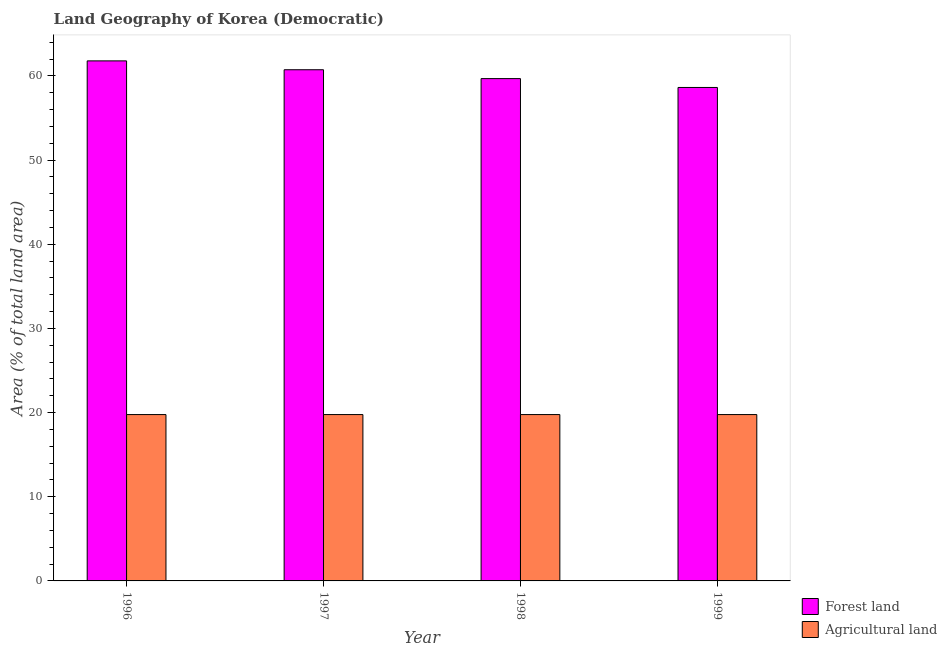How many different coloured bars are there?
Provide a succinct answer. 2. What is the label of the 1st group of bars from the left?
Your answer should be very brief. 1996. In how many cases, is the number of bars for a given year not equal to the number of legend labels?
Provide a succinct answer. 0. What is the percentage of land area under forests in 1999?
Your response must be concise. 58.63. Across all years, what is the maximum percentage of land area under forests?
Keep it short and to the point. 61.79. Across all years, what is the minimum percentage of land area under forests?
Offer a terse response. 58.63. In which year was the percentage of land area under agriculture maximum?
Ensure brevity in your answer.  1996. In which year was the percentage of land area under agriculture minimum?
Your answer should be compact. 1996. What is the total percentage of land area under forests in the graph?
Provide a succinct answer. 240.84. What is the difference between the percentage of land area under forests in 1996 and that in 1998?
Keep it short and to the point. 2.11. What is the difference between the percentage of land area under forests in 1998 and the percentage of land area under agriculture in 1999?
Ensure brevity in your answer.  1.05. What is the average percentage of land area under agriculture per year?
Give a very brief answer. 19.77. In the year 1999, what is the difference between the percentage of land area under agriculture and percentage of land area under forests?
Your response must be concise. 0. In how many years, is the percentage of land area under agriculture greater than 30 %?
Make the answer very short. 0. What is the ratio of the percentage of land area under forests in 1997 to that in 1999?
Provide a succinct answer. 1.04. Is the percentage of land area under forests in 1997 less than that in 1998?
Your answer should be compact. No. Is the difference between the percentage of land area under agriculture in 1996 and 1999 greater than the difference between the percentage of land area under forests in 1996 and 1999?
Your answer should be compact. No. What is the difference between the highest and the lowest percentage of land area under forests?
Ensure brevity in your answer.  3.16. In how many years, is the percentage of land area under agriculture greater than the average percentage of land area under agriculture taken over all years?
Your answer should be very brief. 0. Is the sum of the percentage of land area under agriculture in 1996 and 1999 greater than the maximum percentage of land area under forests across all years?
Ensure brevity in your answer.  Yes. What does the 1st bar from the left in 1996 represents?
Your answer should be compact. Forest land. What does the 1st bar from the right in 1996 represents?
Offer a very short reply. Agricultural land. How many bars are there?
Your answer should be compact. 8. Are all the bars in the graph horizontal?
Give a very brief answer. No. How many years are there in the graph?
Provide a short and direct response. 4. What is the difference between two consecutive major ticks on the Y-axis?
Offer a terse response. 10. Are the values on the major ticks of Y-axis written in scientific E-notation?
Your answer should be very brief. No. Does the graph contain any zero values?
Your answer should be very brief. No. How many legend labels are there?
Your answer should be very brief. 2. How are the legend labels stacked?
Keep it short and to the point. Vertical. What is the title of the graph?
Offer a terse response. Land Geography of Korea (Democratic). Does "Grants" appear as one of the legend labels in the graph?
Your response must be concise. No. What is the label or title of the Y-axis?
Offer a very short reply. Area (% of total land area). What is the Area (% of total land area) in Forest land in 1996?
Provide a succinct answer. 61.79. What is the Area (% of total land area) in Agricultural land in 1996?
Ensure brevity in your answer.  19.77. What is the Area (% of total land area) in Forest land in 1997?
Ensure brevity in your answer.  60.74. What is the Area (% of total land area) in Agricultural land in 1997?
Your response must be concise. 19.77. What is the Area (% of total land area) of Forest land in 1998?
Provide a succinct answer. 59.68. What is the Area (% of total land area) in Agricultural land in 1998?
Offer a terse response. 19.77. What is the Area (% of total land area) in Forest land in 1999?
Give a very brief answer. 58.63. What is the Area (% of total land area) of Agricultural land in 1999?
Your answer should be very brief. 19.77. Across all years, what is the maximum Area (% of total land area) of Forest land?
Offer a terse response. 61.79. Across all years, what is the maximum Area (% of total land area) of Agricultural land?
Offer a terse response. 19.77. Across all years, what is the minimum Area (% of total land area) in Forest land?
Your answer should be compact. 58.63. Across all years, what is the minimum Area (% of total land area) in Agricultural land?
Your answer should be compact. 19.77. What is the total Area (% of total land area) of Forest land in the graph?
Your answer should be very brief. 240.84. What is the total Area (% of total land area) in Agricultural land in the graph?
Offer a terse response. 79.06. What is the difference between the Area (% of total land area) of Forest land in 1996 and that in 1997?
Provide a short and direct response. 1.05. What is the difference between the Area (% of total land area) in Forest land in 1996 and that in 1998?
Provide a short and direct response. 2.11. What is the difference between the Area (% of total land area) in Forest land in 1996 and that in 1999?
Give a very brief answer. 3.16. What is the difference between the Area (% of total land area) in Forest land in 1997 and that in 1998?
Provide a succinct answer. 1.05. What is the difference between the Area (% of total land area) of Forest land in 1997 and that in 1999?
Provide a succinct answer. 2.11. What is the difference between the Area (% of total land area) in Forest land in 1998 and that in 1999?
Make the answer very short. 1.05. What is the difference between the Area (% of total land area) of Agricultural land in 1998 and that in 1999?
Provide a short and direct response. 0. What is the difference between the Area (% of total land area) of Forest land in 1996 and the Area (% of total land area) of Agricultural land in 1997?
Ensure brevity in your answer.  42.02. What is the difference between the Area (% of total land area) of Forest land in 1996 and the Area (% of total land area) of Agricultural land in 1998?
Your answer should be very brief. 42.02. What is the difference between the Area (% of total land area) of Forest land in 1996 and the Area (% of total land area) of Agricultural land in 1999?
Offer a very short reply. 42.02. What is the difference between the Area (% of total land area) in Forest land in 1997 and the Area (% of total land area) in Agricultural land in 1998?
Provide a succinct answer. 40.97. What is the difference between the Area (% of total land area) in Forest land in 1997 and the Area (% of total land area) in Agricultural land in 1999?
Give a very brief answer. 40.97. What is the difference between the Area (% of total land area) of Forest land in 1998 and the Area (% of total land area) of Agricultural land in 1999?
Your response must be concise. 39.92. What is the average Area (% of total land area) in Forest land per year?
Make the answer very short. 60.21. What is the average Area (% of total land area) of Agricultural land per year?
Give a very brief answer. 19.77. In the year 1996, what is the difference between the Area (% of total land area) in Forest land and Area (% of total land area) in Agricultural land?
Offer a terse response. 42.02. In the year 1997, what is the difference between the Area (% of total land area) in Forest land and Area (% of total land area) in Agricultural land?
Give a very brief answer. 40.97. In the year 1998, what is the difference between the Area (% of total land area) in Forest land and Area (% of total land area) in Agricultural land?
Your response must be concise. 39.92. In the year 1999, what is the difference between the Area (% of total land area) in Forest land and Area (% of total land area) in Agricultural land?
Provide a succinct answer. 38.87. What is the ratio of the Area (% of total land area) in Forest land in 1996 to that in 1997?
Offer a terse response. 1.02. What is the ratio of the Area (% of total land area) of Agricultural land in 1996 to that in 1997?
Keep it short and to the point. 1. What is the ratio of the Area (% of total land area) of Forest land in 1996 to that in 1998?
Your answer should be compact. 1.04. What is the ratio of the Area (% of total land area) in Forest land in 1996 to that in 1999?
Ensure brevity in your answer.  1.05. What is the ratio of the Area (% of total land area) of Agricultural land in 1996 to that in 1999?
Make the answer very short. 1. What is the ratio of the Area (% of total land area) in Forest land in 1997 to that in 1998?
Keep it short and to the point. 1.02. What is the ratio of the Area (% of total land area) in Agricultural land in 1997 to that in 1998?
Offer a terse response. 1. What is the ratio of the Area (% of total land area) in Forest land in 1997 to that in 1999?
Offer a terse response. 1.04. What is the ratio of the Area (% of total land area) of Agricultural land in 1997 to that in 1999?
Your answer should be very brief. 1. What is the ratio of the Area (% of total land area) in Agricultural land in 1998 to that in 1999?
Offer a terse response. 1. What is the difference between the highest and the second highest Area (% of total land area) of Forest land?
Provide a short and direct response. 1.05. What is the difference between the highest and the second highest Area (% of total land area) of Agricultural land?
Offer a very short reply. 0. What is the difference between the highest and the lowest Area (% of total land area) in Forest land?
Give a very brief answer. 3.16. What is the difference between the highest and the lowest Area (% of total land area) in Agricultural land?
Your answer should be compact. 0. 